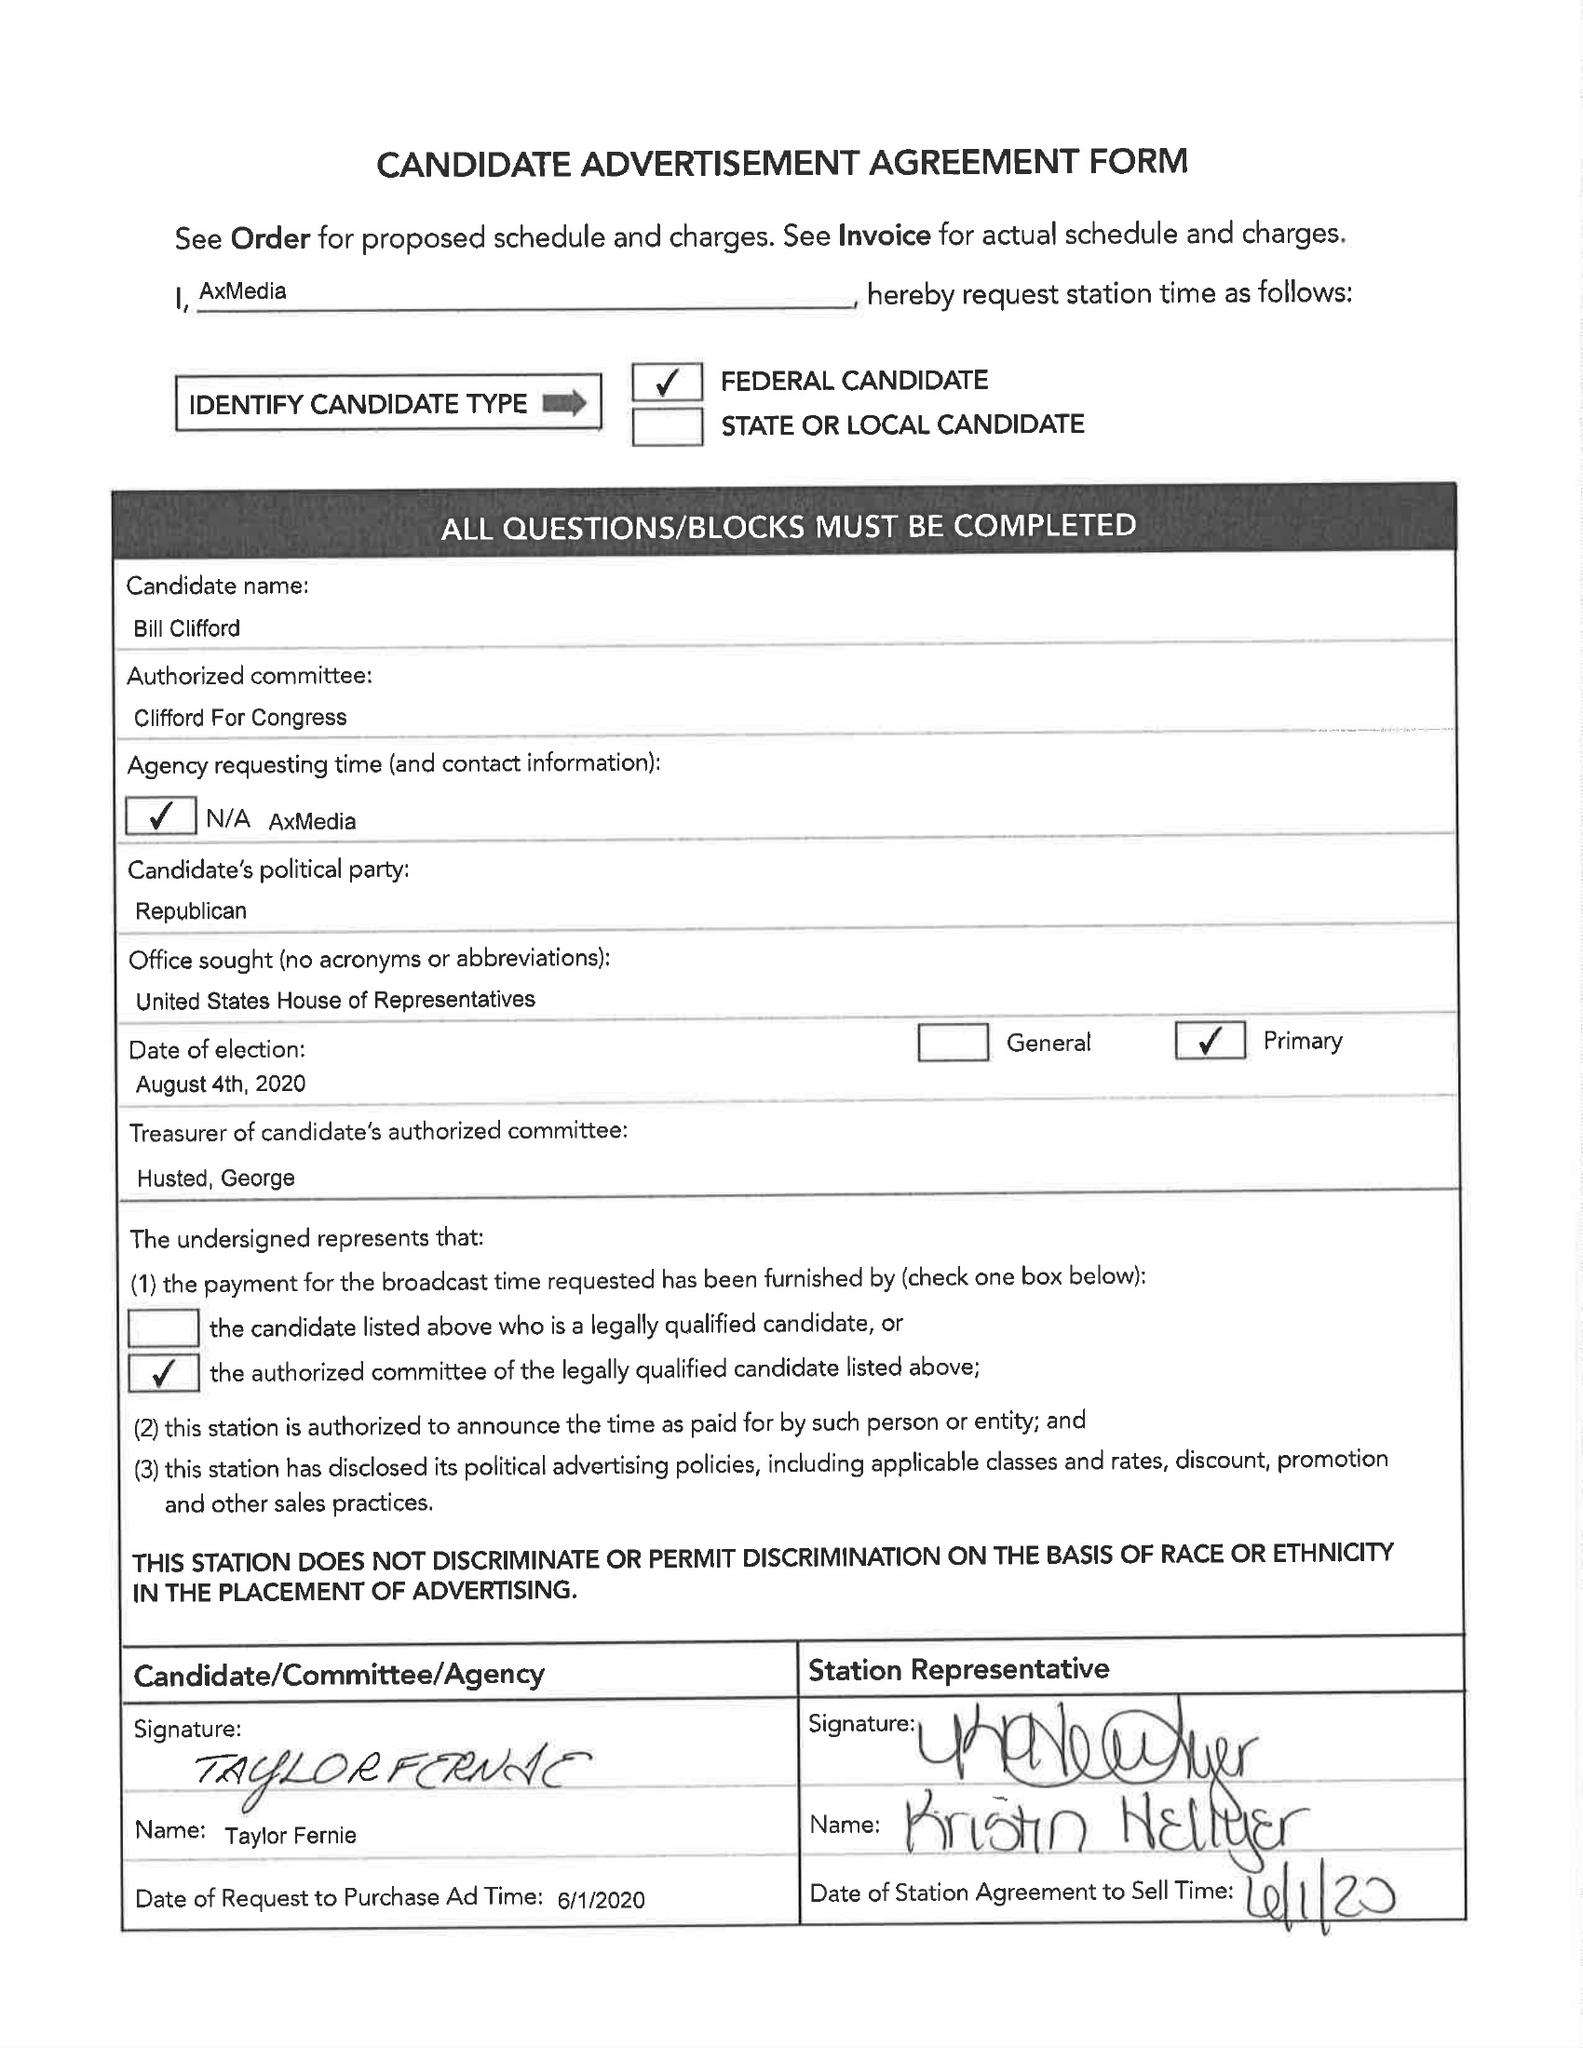What is the value for the flight_from?
Answer the question using a single word or phrase. 06/02/20 